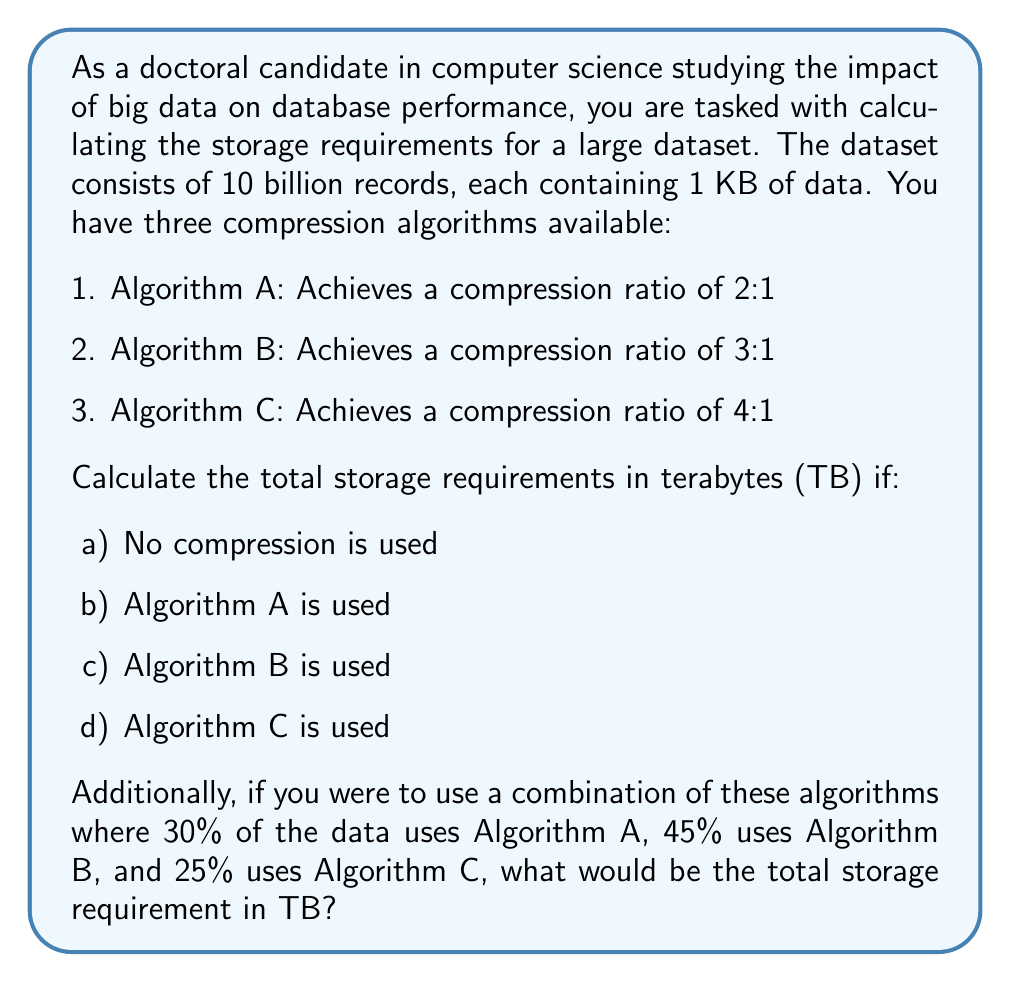Could you help me with this problem? Let's approach this problem step by step:

1. Calculate the total uncompressed data size:
   $$ \text{Total size} = 10 \text{ billion} \times 1 \text{ KB} = 10^{10} \text{ KB} = 10^{7} \text{ MB} = 10^{4} \text{ GB} = 10 \text{ TB} $$

2. Calculate storage requirements for each scenario:

   a) No compression: 10 TB

   b) Algorithm A (2:1 ratio):
      $$ \text{Storage} = \frac{10 \text{ TB}}{2} = 5 \text{ TB} $$

   c) Algorithm B (3:1 ratio):
      $$ \text{Storage} = \frac{10 \text{ TB}}{3} \approx 3.33 \text{ TB} $$

   d) Algorithm C (4:1 ratio):
      $$ \text{Storage} = \frac{10 \text{ TB}}{4} = 2.5 \text{ TB} $$

3. For the combination of algorithms:
   - 30% uses Algorithm A: $0.3 \times 10 \text{ TB} = 3 \text{ TB}$ uncompressed
   - 45% uses Algorithm B: $0.45 \times 10 \text{ TB} = 4.5 \text{ TB}$ uncompressed
   - 25% uses Algorithm C: $0.25 \times 10 \text{ TB} = 2.5 \text{ TB}$ uncompressed

   Now, apply compression to each portion:
   $$ \text{Algorithm A portion} = \frac{3 \text{ TB}}{2} = 1.5 \text{ TB} $$
   $$ \text{Algorithm B portion} = \frac{4.5 \text{ TB}}{3} = 1.5 \text{ TB} $$
   $$ \text{Algorithm C portion} = \frac{2.5 \text{ TB}}{4} = 0.625 \text{ TB} $$

   Total storage for combined algorithms:
   $$ \text{Total} = 1.5 \text{ TB} + 1.5 \text{ TB} + 0.625 \text{ TB} = 3.625 \text{ TB} $$
Answer: a) No compression: 10 TB
b) Algorithm A: 5 TB
c) Algorithm B: 3.33 TB
d) Algorithm C: 2.5 TB
Combination of algorithms: 3.625 TB 